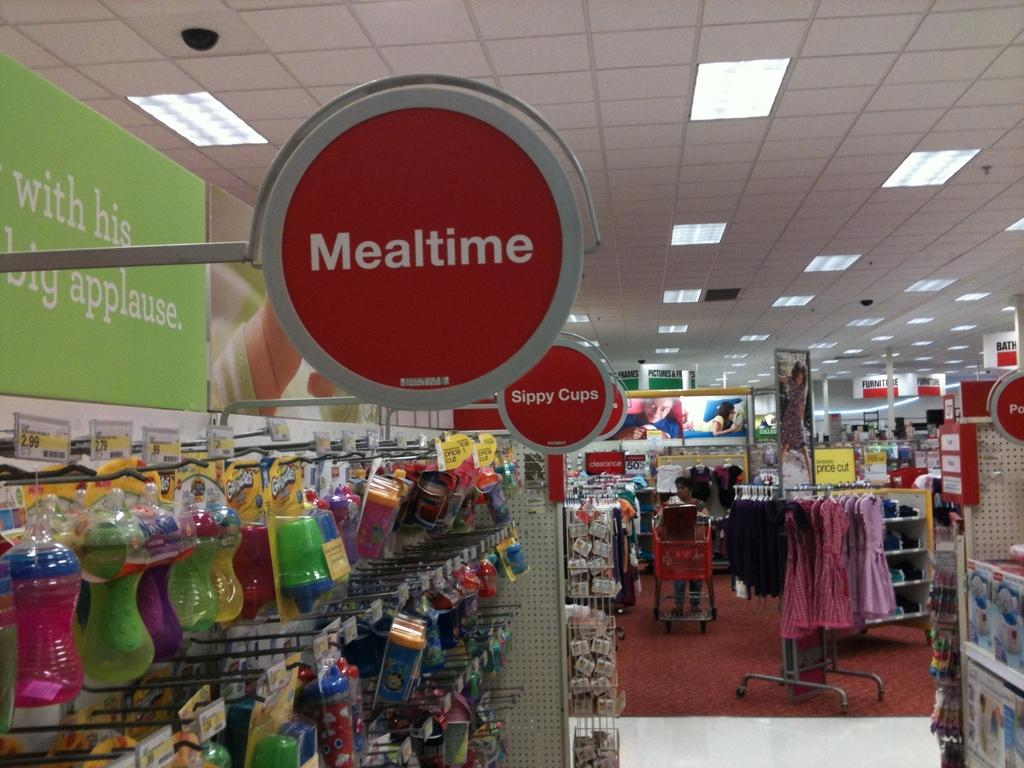<image>
Relay a brief, clear account of the picture shown. A store isle labeled meal time and sippy cups. 